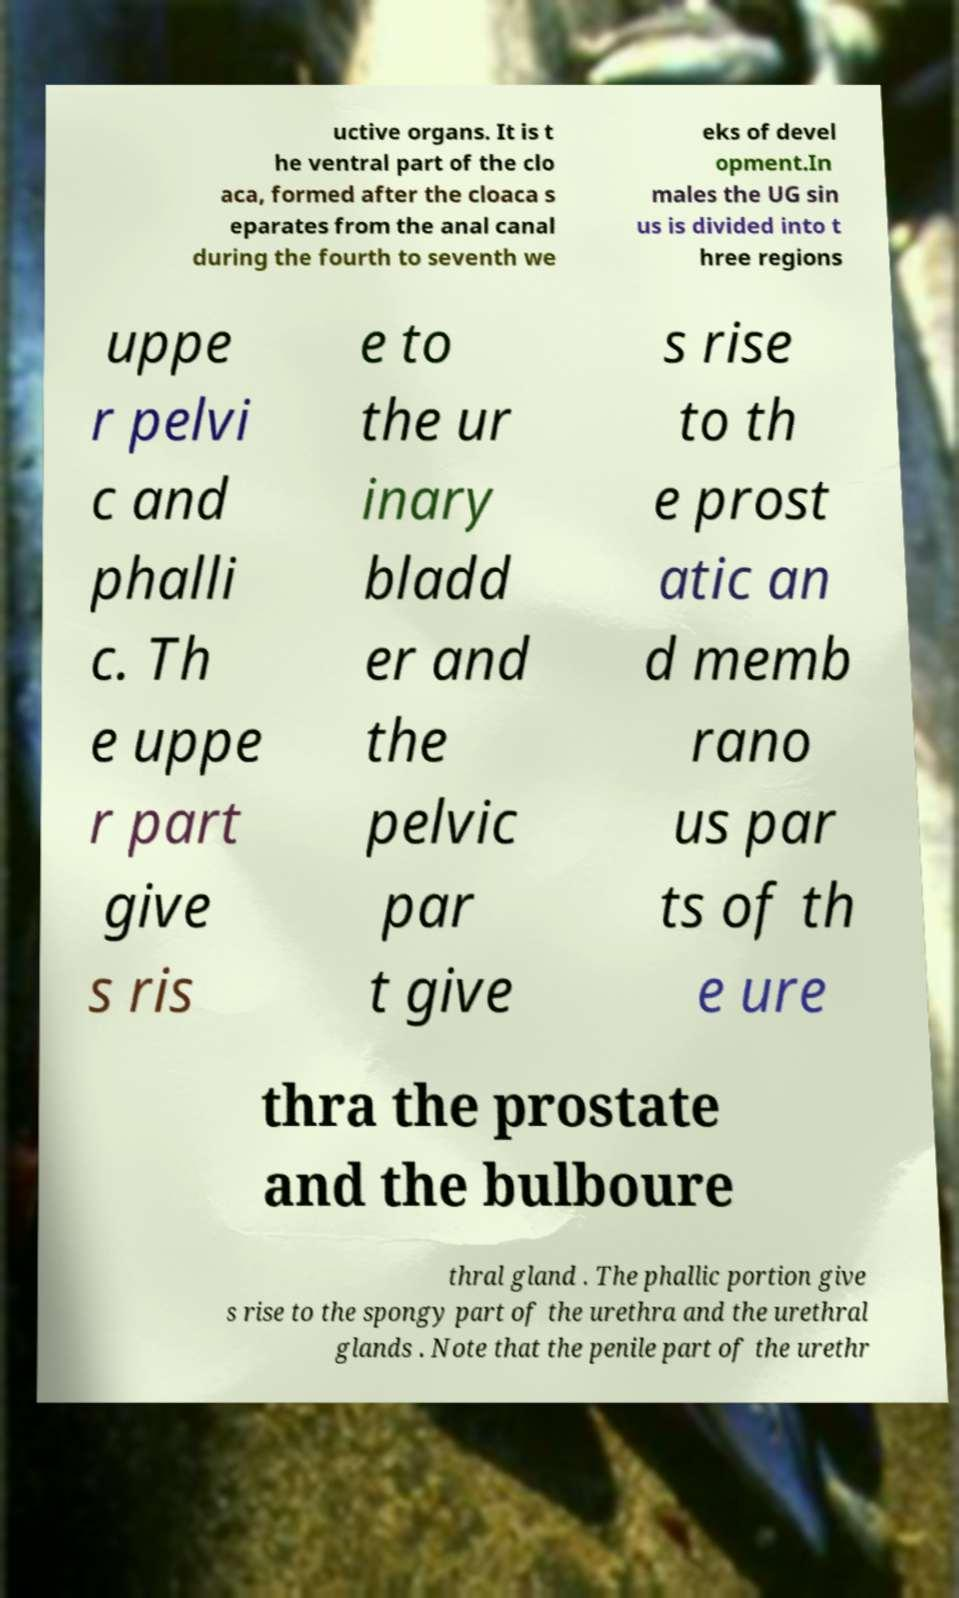What messages or text are displayed in this image? I need them in a readable, typed format. uctive organs. It is t he ventral part of the clo aca, formed after the cloaca s eparates from the anal canal during the fourth to seventh we eks of devel opment.In males the UG sin us is divided into t hree regions uppe r pelvi c and phalli c. Th e uppe r part give s ris e to the ur inary bladd er and the pelvic par t give s rise to th e prost atic an d memb rano us par ts of th e ure thra the prostate and the bulboure thral gland . The phallic portion give s rise to the spongy part of the urethra and the urethral glands . Note that the penile part of the urethr 